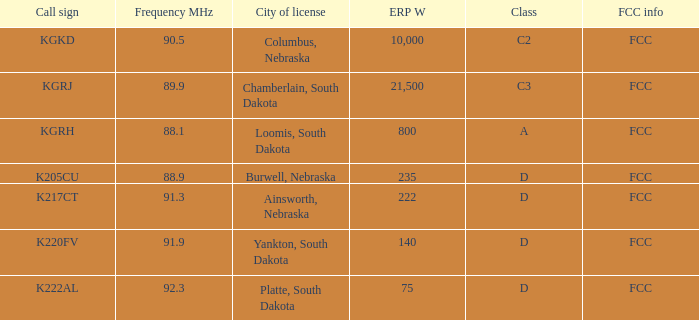What is the average frequency mhz of the loomis, south dakota city license? 88.1. 